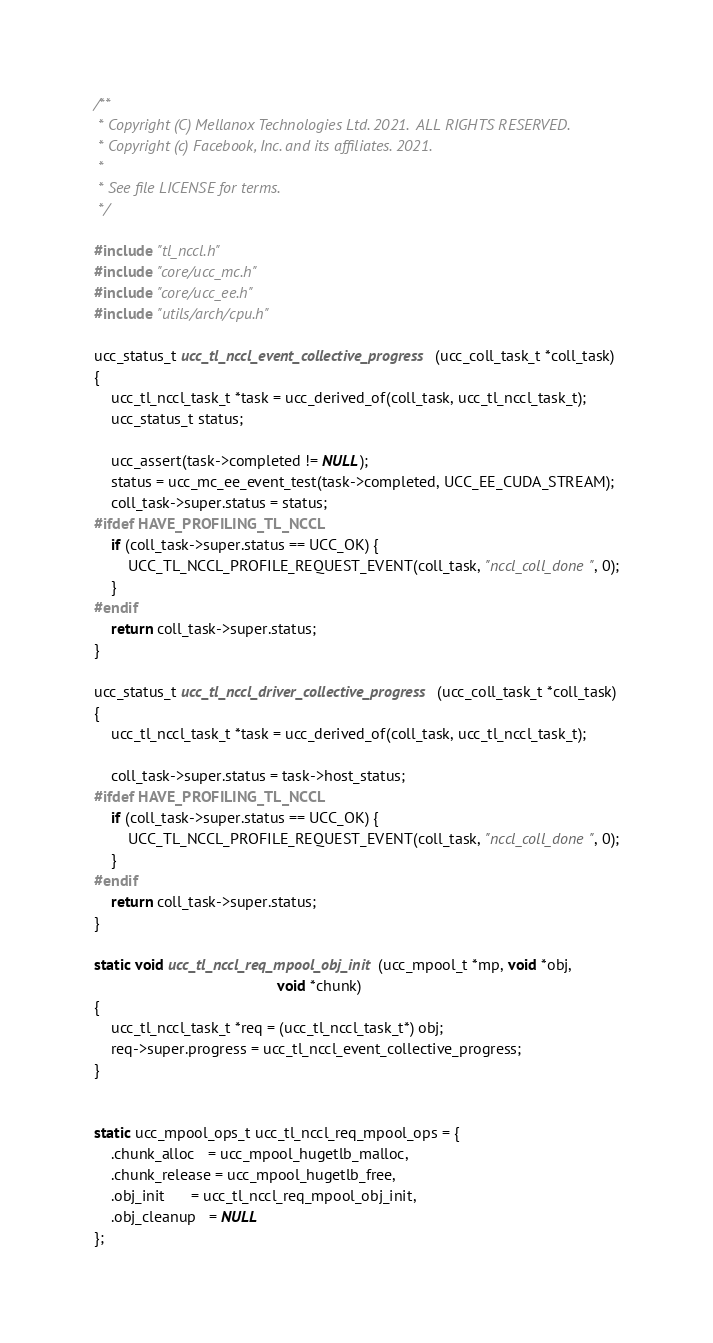<code> <loc_0><loc_0><loc_500><loc_500><_C_>/**
 * Copyright (C) Mellanox Technologies Ltd. 2021.  ALL RIGHTS RESERVED.
 * Copyright (c) Facebook, Inc. and its affiliates. 2021.
 *
 * See file LICENSE for terms.
 */

#include "tl_nccl.h"
#include "core/ucc_mc.h"
#include "core/ucc_ee.h"
#include "utils/arch/cpu.h"

ucc_status_t ucc_tl_nccl_event_collective_progress(ucc_coll_task_t *coll_task)
{
    ucc_tl_nccl_task_t *task = ucc_derived_of(coll_task, ucc_tl_nccl_task_t);
    ucc_status_t status;

    ucc_assert(task->completed != NULL);
    status = ucc_mc_ee_event_test(task->completed, UCC_EE_CUDA_STREAM);
    coll_task->super.status = status;
#ifdef HAVE_PROFILING_TL_NCCL
    if (coll_task->super.status == UCC_OK) {
        UCC_TL_NCCL_PROFILE_REQUEST_EVENT(coll_task, "nccl_coll_done", 0);
    }
#endif
    return coll_task->super.status;
}

ucc_status_t ucc_tl_nccl_driver_collective_progress(ucc_coll_task_t *coll_task)
{
    ucc_tl_nccl_task_t *task = ucc_derived_of(coll_task, ucc_tl_nccl_task_t);

    coll_task->super.status = task->host_status;
#ifdef HAVE_PROFILING_TL_NCCL
    if (coll_task->super.status == UCC_OK) {
        UCC_TL_NCCL_PROFILE_REQUEST_EVENT(coll_task, "nccl_coll_done", 0);
    }
#endif
    return coll_task->super.status;
}

static void ucc_tl_nccl_req_mpool_obj_init(ucc_mpool_t *mp, void *obj,
                                           void *chunk)
{
    ucc_tl_nccl_task_t *req = (ucc_tl_nccl_task_t*) obj;
    req->super.progress = ucc_tl_nccl_event_collective_progress;
}


static ucc_mpool_ops_t ucc_tl_nccl_req_mpool_ops = {
    .chunk_alloc   = ucc_mpool_hugetlb_malloc,
    .chunk_release = ucc_mpool_hugetlb_free,
    .obj_init      = ucc_tl_nccl_req_mpool_obj_init,
    .obj_cleanup   = NULL
};
</code> 